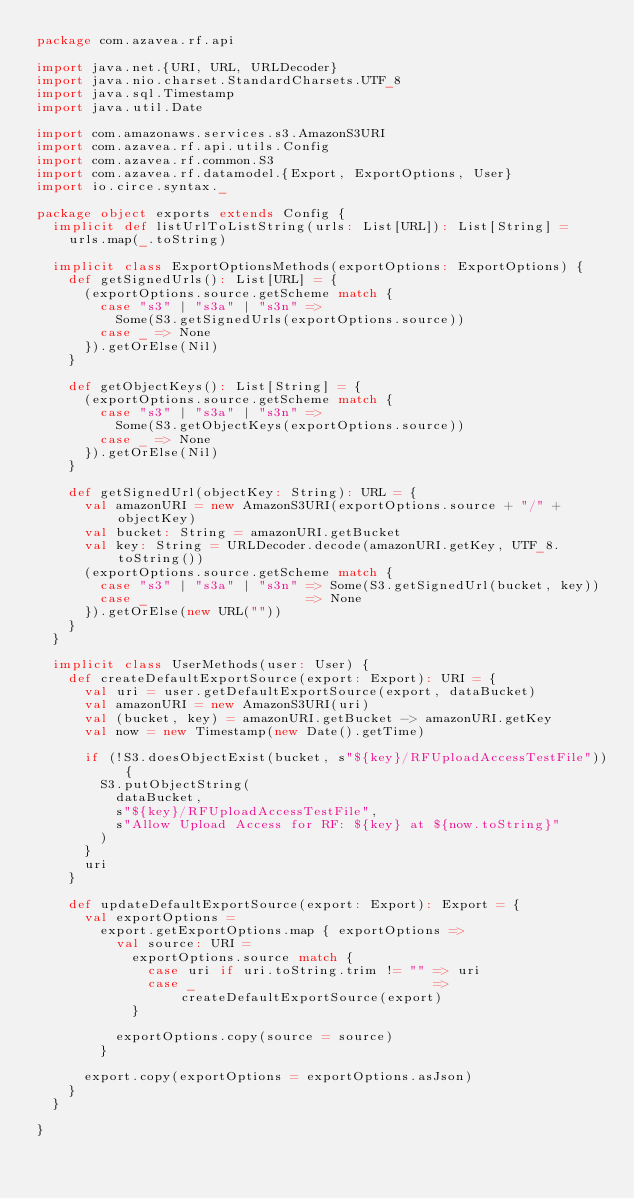Convert code to text. <code><loc_0><loc_0><loc_500><loc_500><_Scala_>package com.azavea.rf.api

import java.net.{URI, URL, URLDecoder}
import java.nio.charset.StandardCharsets.UTF_8
import java.sql.Timestamp
import java.util.Date

import com.amazonaws.services.s3.AmazonS3URI
import com.azavea.rf.api.utils.Config
import com.azavea.rf.common.S3
import com.azavea.rf.datamodel.{Export, ExportOptions, User}
import io.circe.syntax._

package object exports extends Config {
  implicit def listUrlToListString(urls: List[URL]): List[String] =
    urls.map(_.toString)

  implicit class ExportOptionsMethods(exportOptions: ExportOptions) {
    def getSignedUrls(): List[URL] = {
      (exportOptions.source.getScheme match {
        case "s3" | "s3a" | "s3n" =>
          Some(S3.getSignedUrls(exportOptions.source))
        case _ => None
      }).getOrElse(Nil)
    }

    def getObjectKeys(): List[String] = {
      (exportOptions.source.getScheme match {
        case "s3" | "s3a" | "s3n" =>
          Some(S3.getObjectKeys(exportOptions.source))
        case _ => None
      }).getOrElse(Nil)
    }

    def getSignedUrl(objectKey: String): URL = {
      val amazonURI = new AmazonS3URI(exportOptions.source + "/" + objectKey)
      val bucket: String = amazonURI.getBucket
      val key: String = URLDecoder.decode(amazonURI.getKey, UTF_8.toString())
      (exportOptions.source.getScheme match {
        case "s3" | "s3a" | "s3n" => Some(S3.getSignedUrl(bucket, key))
        case _                    => None
      }).getOrElse(new URL(""))
    }
  }

  implicit class UserMethods(user: User) {
    def createDefaultExportSource(export: Export): URI = {
      val uri = user.getDefaultExportSource(export, dataBucket)
      val amazonURI = new AmazonS3URI(uri)
      val (bucket, key) = amazonURI.getBucket -> amazonURI.getKey
      val now = new Timestamp(new Date().getTime)

      if (!S3.doesObjectExist(bucket, s"${key}/RFUploadAccessTestFile")) {
        S3.putObjectString(
          dataBucket,
          s"${key}/RFUploadAccessTestFile",
          s"Allow Upload Access for RF: ${key} at ${now.toString}"
        )
      }
      uri
    }

    def updateDefaultExportSource(export: Export): Export = {
      val exportOptions =
        export.getExportOptions.map { exportOptions =>
          val source: URI =
            exportOptions.source match {
              case uri if uri.toString.trim != "" => uri
              case _                              => createDefaultExportSource(export)
            }

          exportOptions.copy(source = source)
        }

      export.copy(exportOptions = exportOptions.asJson)
    }
  }

}
</code> 